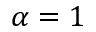Convert formula to latex. <formula><loc_0><loc_0><loc_500><loc_500>\alpha = 1</formula> 